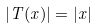Convert formula to latex. <formula><loc_0><loc_0><loc_500><loc_500>| T ( x ) | = | x |</formula> 